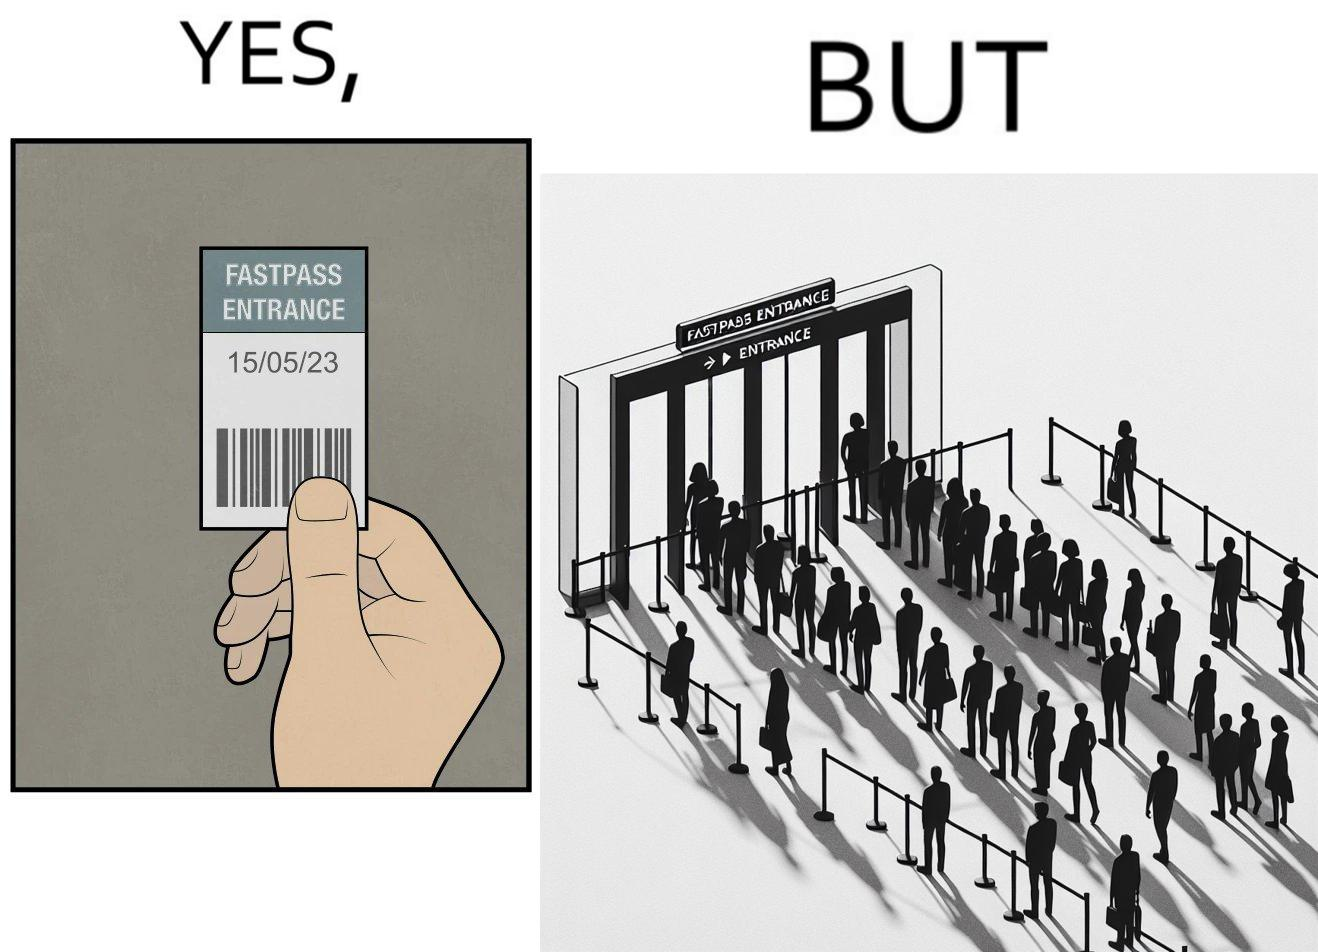Describe the content of this image. The image is ironic, because fast pass entrance was meant for people to pass the gate fast but as more no. of people bought the pass due to which the queue has become longer and it becomes slow and time consuming 